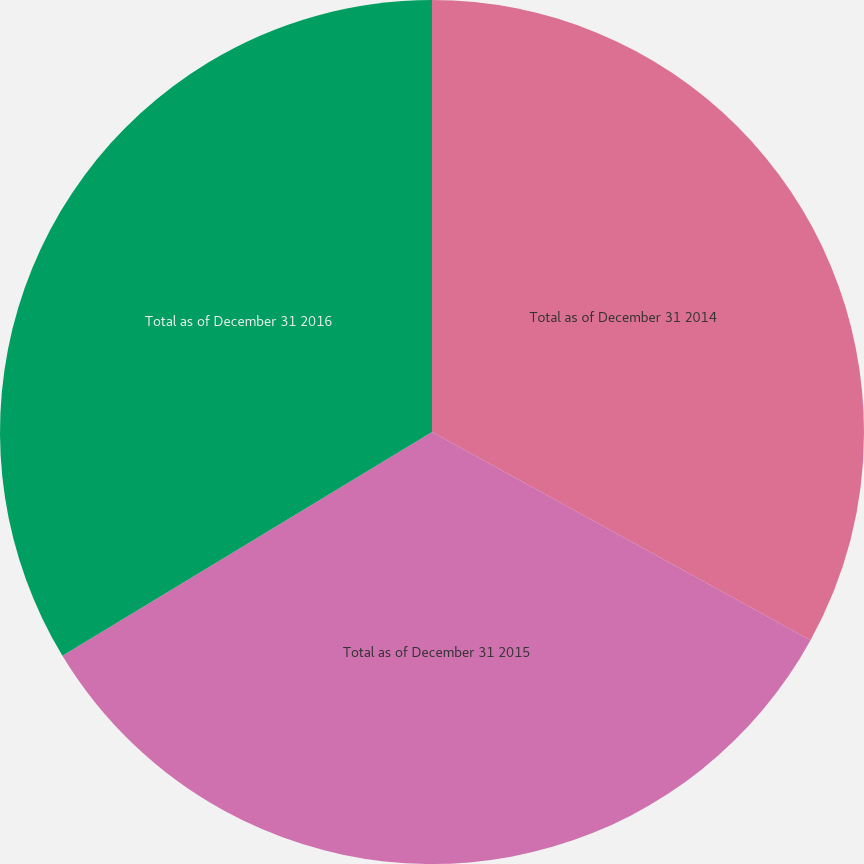<chart> <loc_0><loc_0><loc_500><loc_500><pie_chart><fcel>Total as of December 31 2014<fcel>Total as of December 31 2015<fcel>Total as of December 31 2016<nl><fcel>33.0%<fcel>33.33%<fcel>33.66%<nl></chart> 